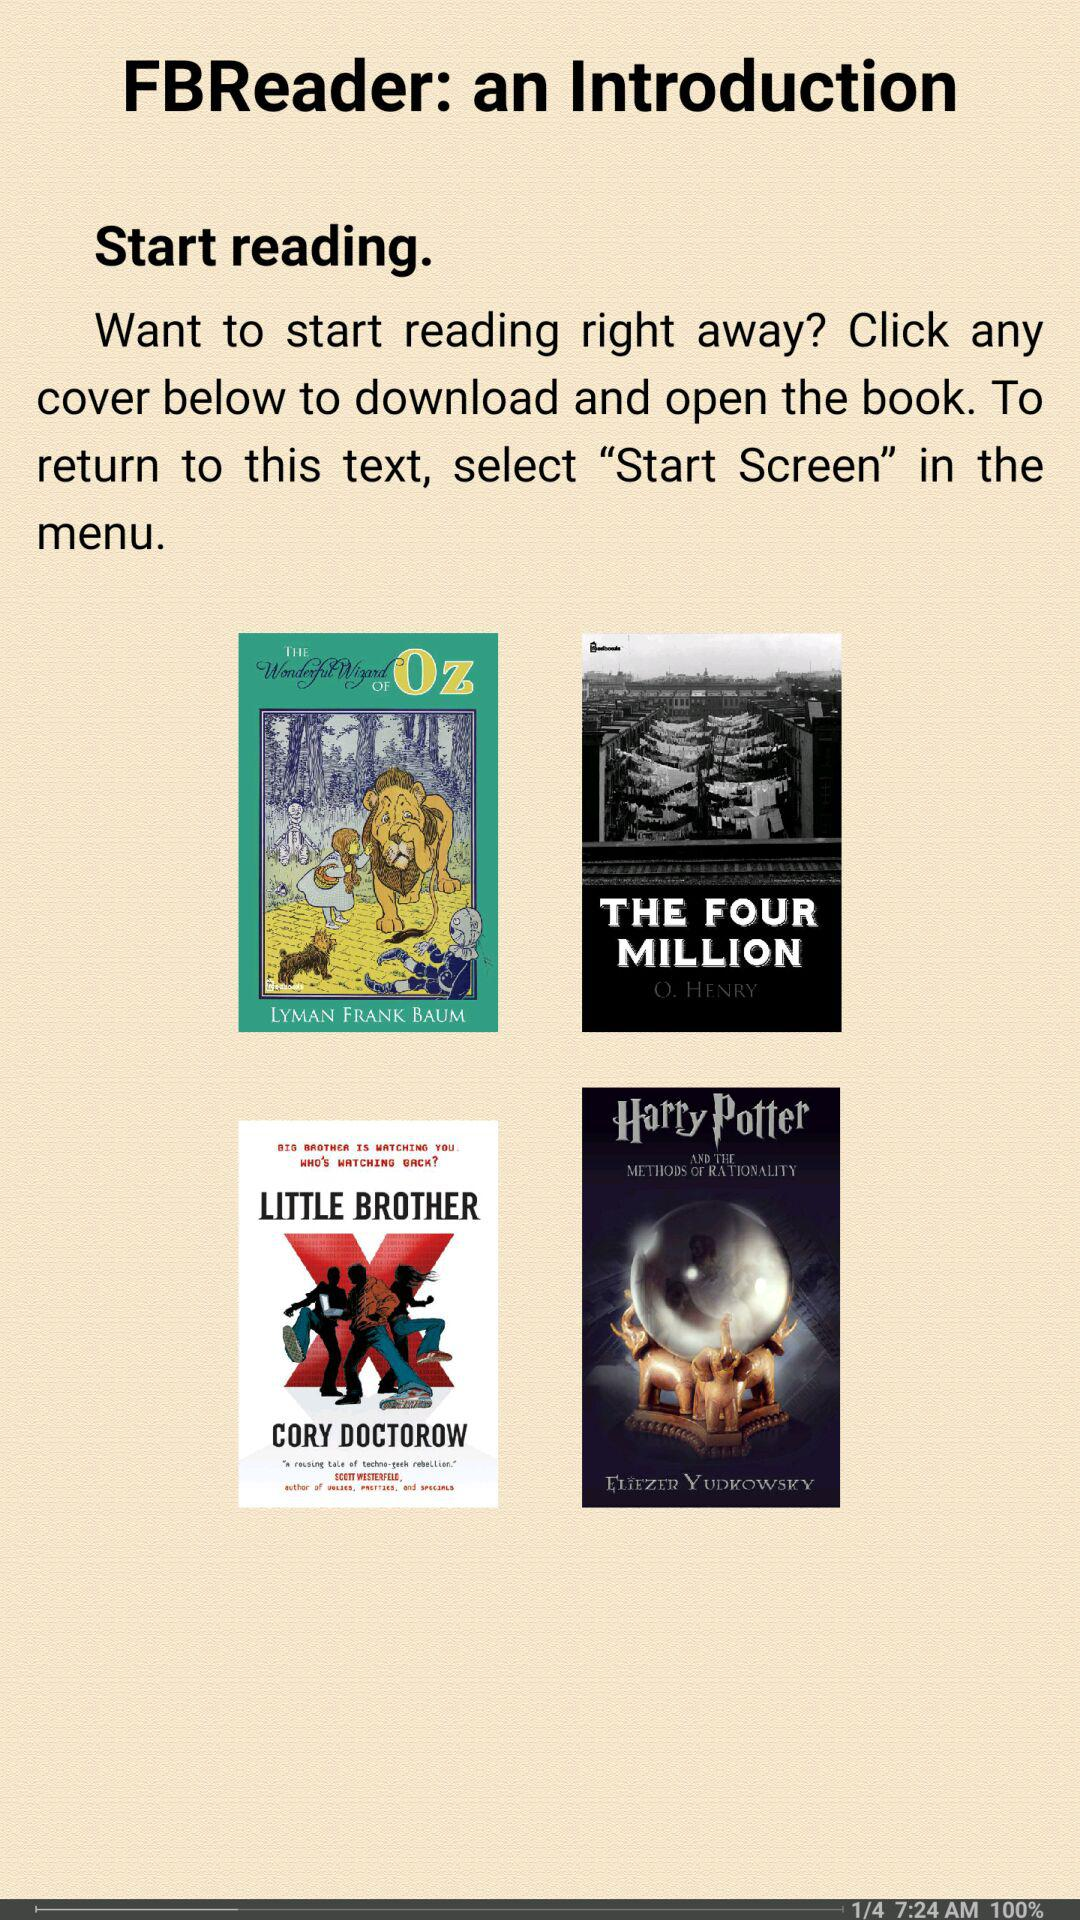How many books are available for download?
Answer the question using a single word or phrase. 4 